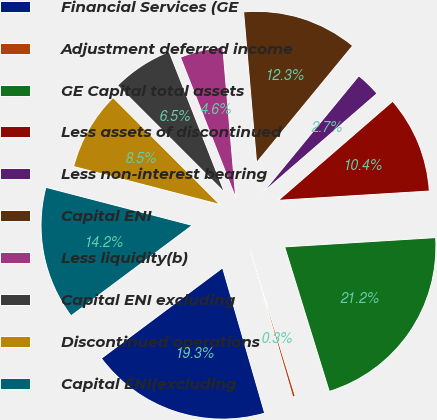Convert chart. <chart><loc_0><loc_0><loc_500><loc_500><pie_chart><fcel>Financial Services (GE<fcel>Adjustment deferred income<fcel>GE Capital total assets<fcel>Less assets of discontinued<fcel>Less non-interest bearing<fcel>Capital ENI<fcel>Less liquidity(b)<fcel>Capital ENI excluding<fcel>Discontinued operations<fcel>Capital ENI(excluding<nl><fcel>19.28%<fcel>0.28%<fcel>21.21%<fcel>10.39%<fcel>2.68%<fcel>12.32%<fcel>4.6%<fcel>6.53%<fcel>8.46%<fcel>14.25%<nl></chart> 